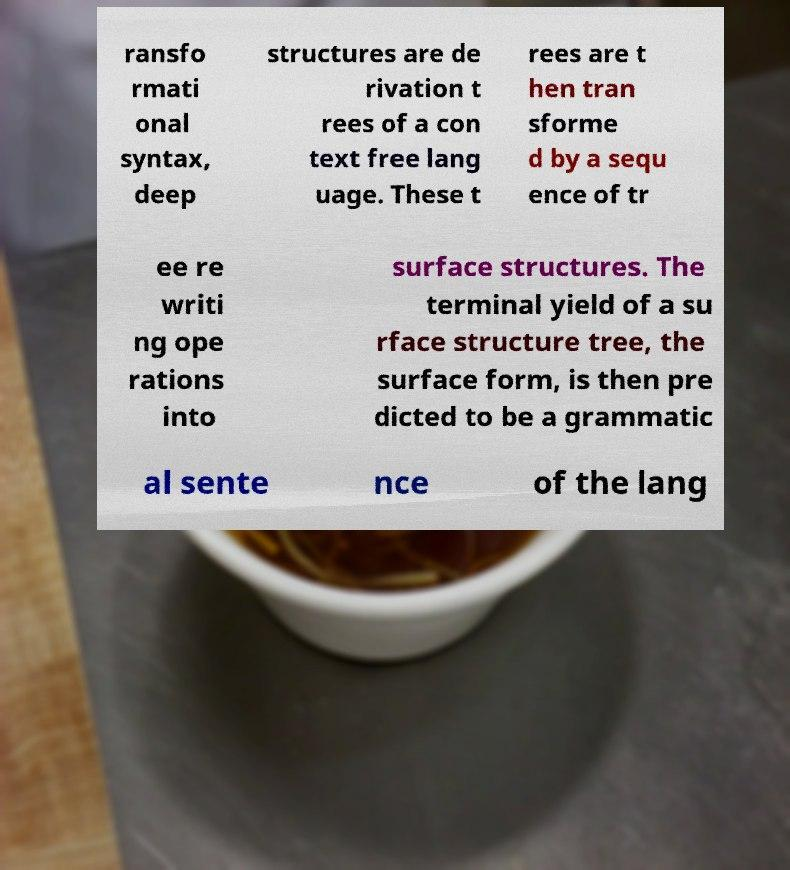I need the written content from this picture converted into text. Can you do that? ransfo rmati onal syntax, deep structures are de rivation t rees of a con text free lang uage. These t rees are t hen tran sforme d by a sequ ence of tr ee re writi ng ope rations into surface structures. The terminal yield of a su rface structure tree, the surface form, is then pre dicted to be a grammatic al sente nce of the lang 